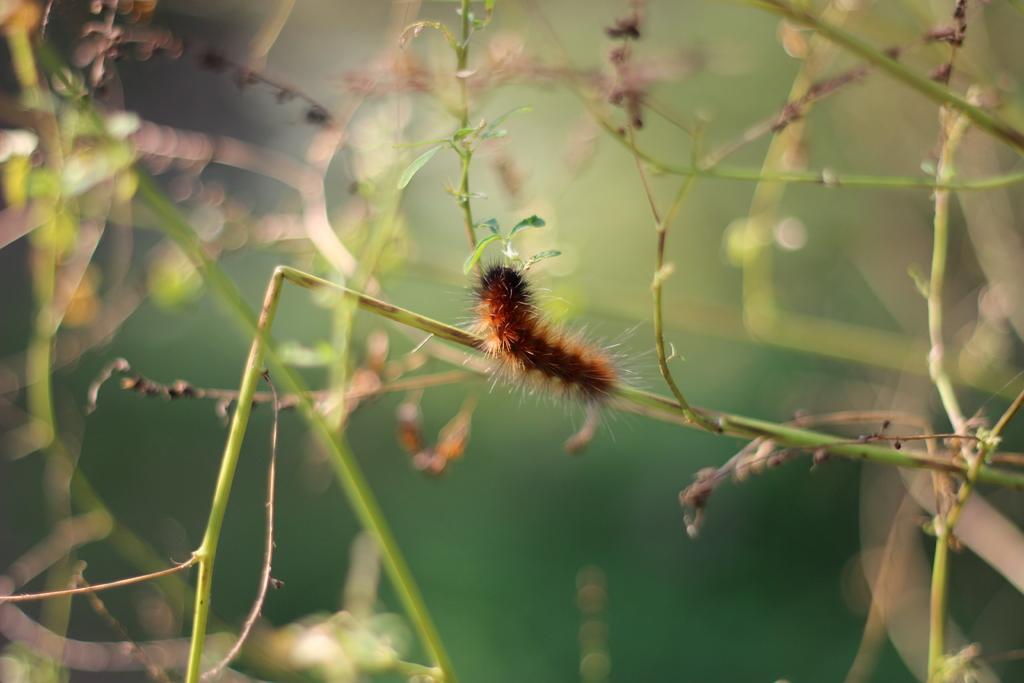Describe this image in one or two sentences. In the center of the image there is a insect on the plant stem. The background of the image is blur. 